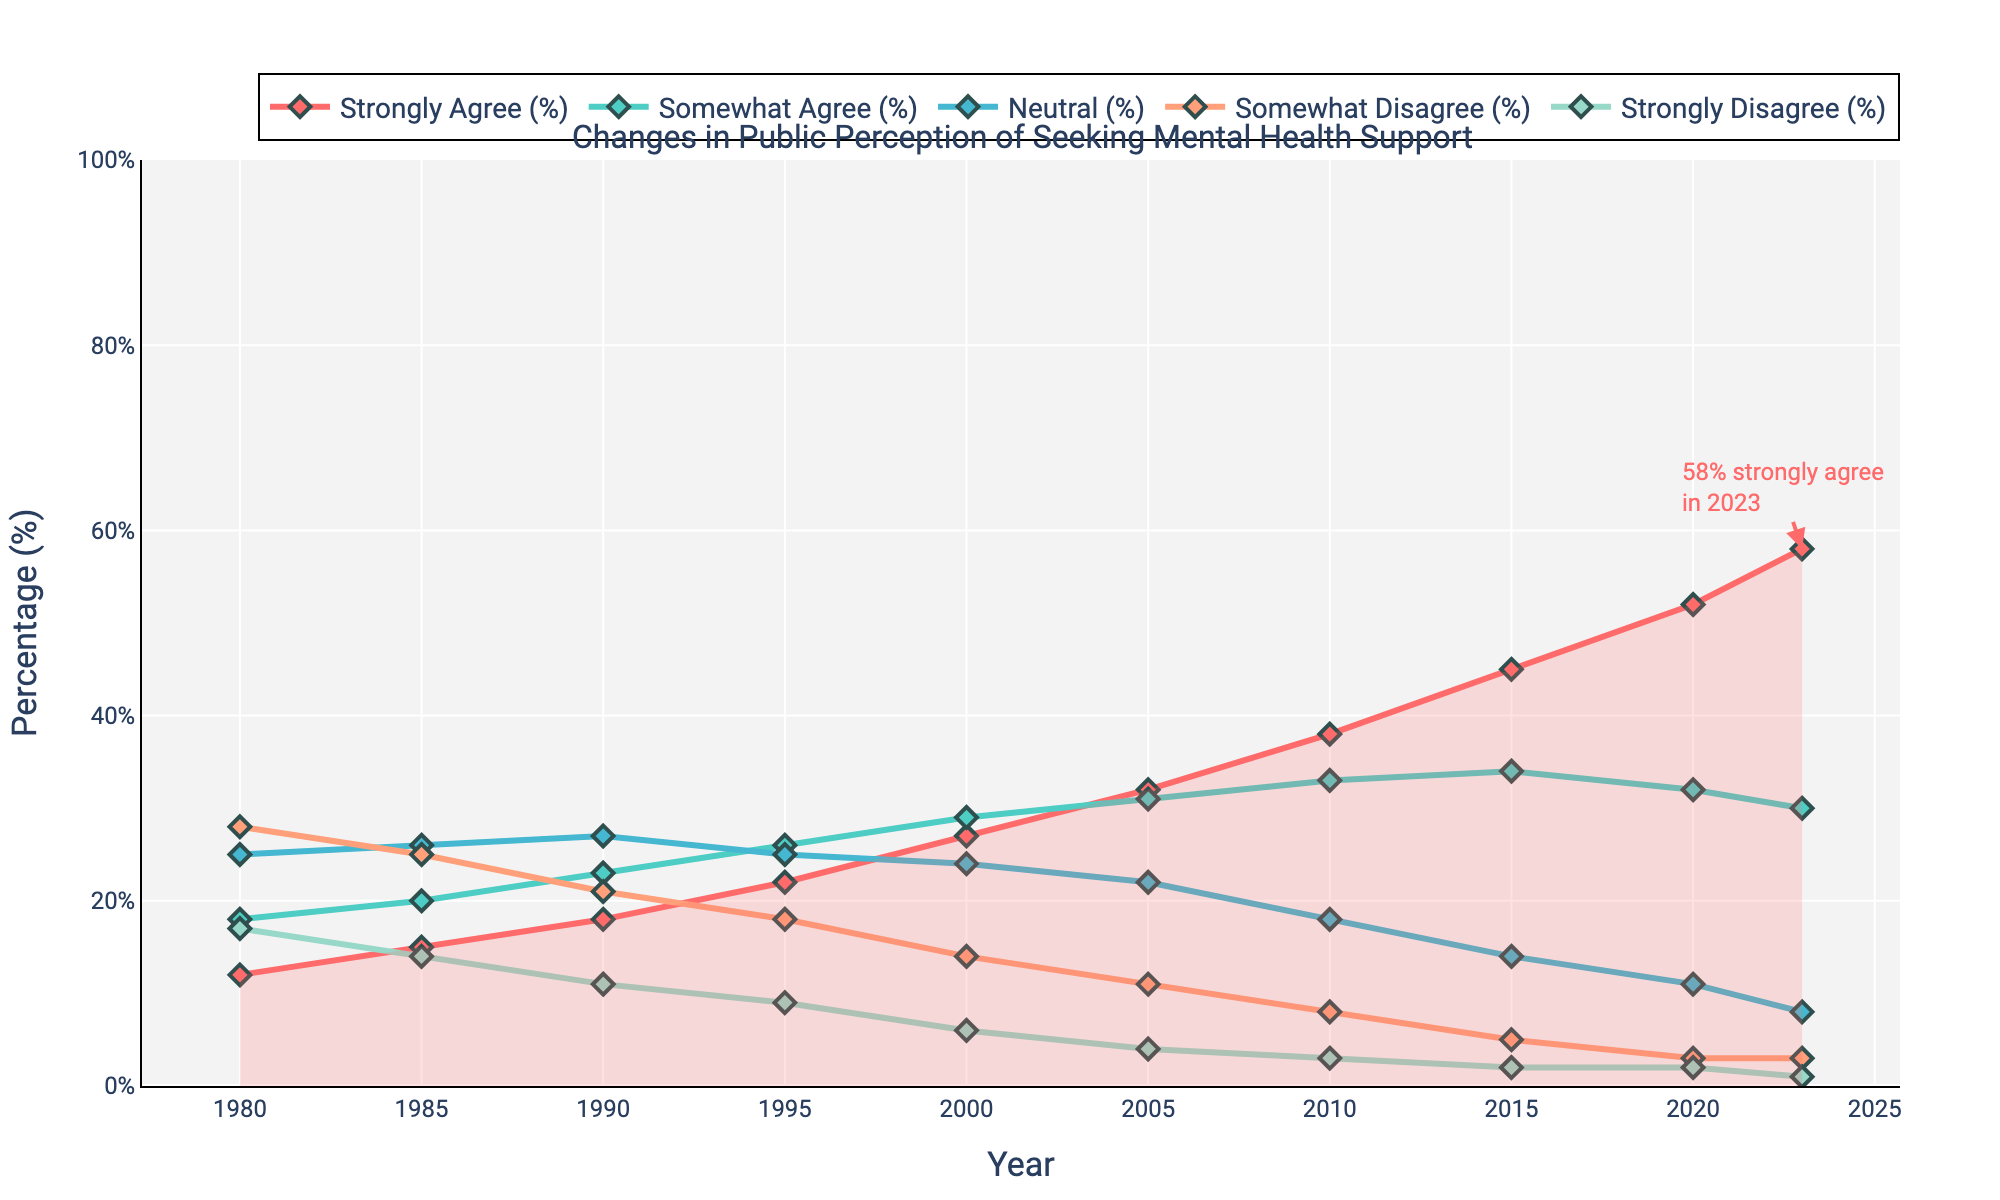What is the percentage change in 'Strongly Agree' from 1980 to 2023? The percentage of 'Strongly Agree' in 1980 was 12% and in 2023 it is 58%. The change is calculated as 58% - 12% = 46%.
Answer: 46% Which year had the highest percentage of 'Strongly Disagree'? By checking each data point in the 'Strongly Disagree' series, we find that 1980 had the highest percentage at 17%.
Answer: 1980 How does the percentage of 'Somewhat Agree' compare between 2000 and 2023? The percentage of 'Somewhat Agree' in 2000 was 29%, while in 2023 it is 30%. Thus, in 2023, it is 1% higher.
Answer: 1% higher What is the total percentage for 'Strongly Disagree' over the entire period? Summing the 'Strongly Disagree' percentages from each year (17 + 14 + 11 + 9 + 6 + 4 + 3 + 2 + 2 + 1) totals 69%.
Answer: 69% Between which two consecutive years did the 'Strongly Agree' percentage increase the most? Checking the increase between each year, the largest increase is from 2015 to 2020, where the percentage went from 45% to 52%, an increase of 7%.
Answer: 2015 to 2020 In which year do 'Somewhat Agree' and 'Neutral' have the smallest difference? The smallest difference between 'Somewhat Agree' and 'Neutral' is in 2000, where 'Somewhat Agree' is 29% and 'Neutral' is 24%, a difference of 5%.
Answer: 2000 Which category had the biggest decline from 1980 to 2023? Comparing the start and end percentages for each category, 'Strongly Disagree' decreased from 17% in 1980 to 1% in 2023, a decline of 16%.
Answer: 'Strongly Disagree' What is the average percentage of 'Neutral' responses from 1980 to 2023? Summing up the 'Neutral' percentages (25 + 26 + 27 + 25 + 24 + 22 + 18 + 14 + 11 + 8) gives 200. Dividing by the number of years (10) gives an average of 20%.
Answer: 20% Which year indicates the lowest public agreement ('Strongly Agree' + 'Somewhat Agree') with seeking mental health support? Summing 'Strongly Agree' and 'Somewhat Agree' for each year, we find 1980 has the lowest total: 12% + 18% = 30%.
Answer: 1980 